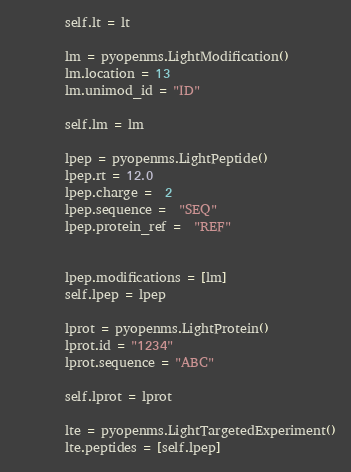Convert code to text. <code><loc_0><loc_0><loc_500><loc_500><_Python_>        self.lt = lt

        lm = pyopenms.LightModification()
        lm.location = 13
        lm.unimod_id = "ID"

        self.lm = lm

        lpep = pyopenms.LightPeptide()
        lpep.rt = 12.0
        lpep.charge =  2
        lpep.sequence =  "SEQ"
        lpep.protein_ref =  "REF"


        lpep.modifications = [lm]
        self.lpep = lpep

        lprot = pyopenms.LightProtein()
        lprot.id = "1234"
        lprot.sequence = "ABC"

        self.lprot = lprot

        lte = pyopenms.LightTargetedExperiment()
        lte.peptides = [self.lpep]</code> 